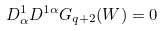Convert formula to latex. <formula><loc_0><loc_0><loc_500><loc_500>D ^ { 1 } _ { \alpha } D ^ { 1 \alpha } G _ { q + 2 } ( W ) = 0</formula> 